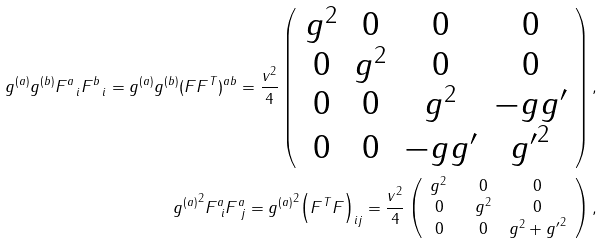<formula> <loc_0><loc_0><loc_500><loc_500>g ^ { ( a ) } g ^ { ( b ) } F ^ { a } _ { \ i } F ^ { b } _ { \ i } = g ^ { ( a ) } g ^ { ( b ) } ( F F ^ { T } ) ^ { a b } = \frac { v ^ { 2 } } 4 \left ( \begin{array} { * { 4 } { c } } g ^ { 2 } & 0 & 0 & 0 \\ 0 & g ^ { 2 } & 0 & 0 \\ 0 & 0 & g ^ { 2 } & - g g ^ { \prime } \\ 0 & 0 & - g g ^ { \prime } & { g ^ { \prime } } ^ { 2 } \\ \end{array} \right ) , \\ { g ^ { ( a ) } } ^ { 2 } F ^ { a } _ { \ i } F ^ { a } _ { \ j } = { g ^ { ( a ) } } ^ { 2 } \Big { ( } F ^ { T } F \Big { ) } _ { i j } = \frac { v ^ { 2 } } 4 \left ( \begin{array} { * { 3 } { c } } g ^ { 2 } \ \ & 0 & 0 \\ 0 \ \ & g ^ { 2 } & 0 \\ 0 \ \ & 0 & g ^ { 2 } + { g ^ { \prime } } ^ { 2 } \\ \end{array} \right ) ,</formula> 